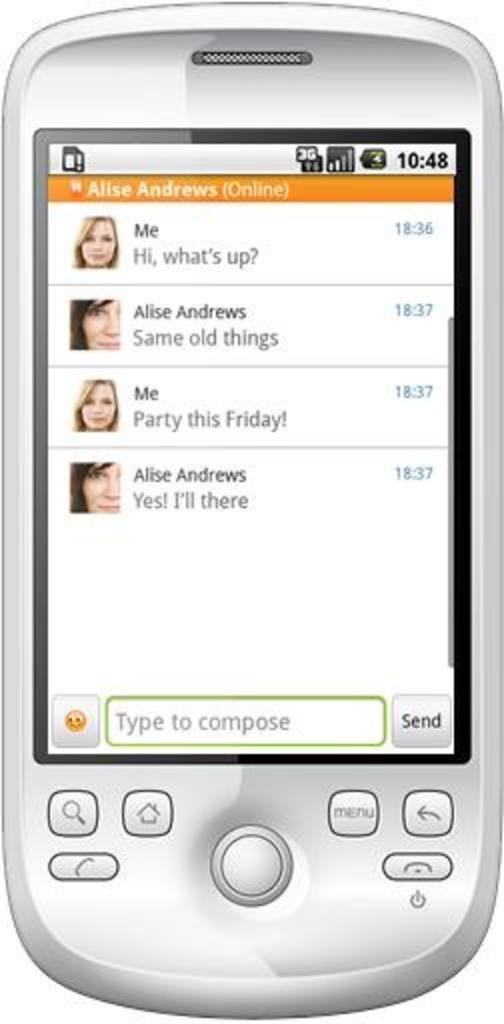<image>
Create a compact narrative representing the image presented. A generic cell phone displaying the texts of Alise Andrews. 